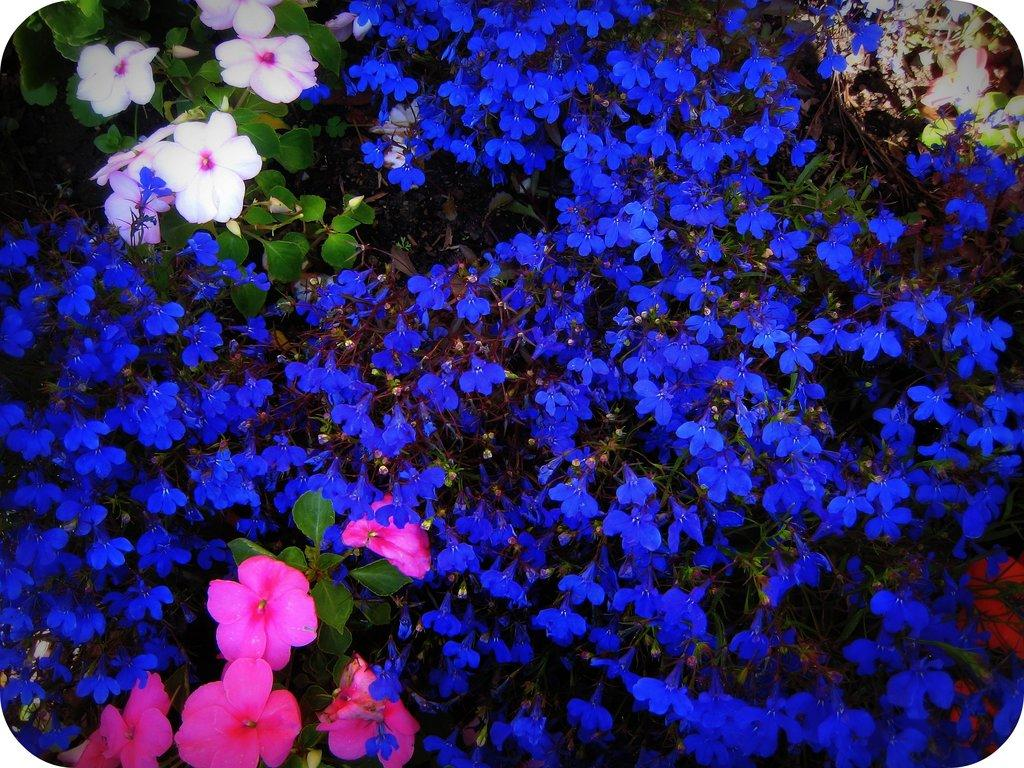What is the main subject of the image? The main subject of the image is flowers. What colors can be seen in the flowers? The flowers are in blue, pink, and white colors. What else is present in the image besides flowers? There are leaves in the image. What color are the leaves? The leaves are green in color. Can you observe any fowl in the image? There is no fowl present in the image; it features flowers and leaves. Is there a knot tied in any of the flowers in the image? There is no knot present in the image; it features flowers and leaves in various colors. 